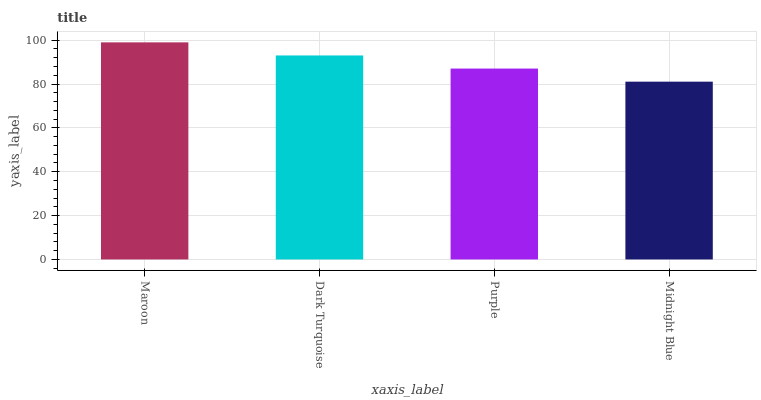Is Midnight Blue the minimum?
Answer yes or no. Yes. Is Maroon the maximum?
Answer yes or no. Yes. Is Dark Turquoise the minimum?
Answer yes or no. No. Is Dark Turquoise the maximum?
Answer yes or no. No. Is Maroon greater than Dark Turquoise?
Answer yes or no. Yes. Is Dark Turquoise less than Maroon?
Answer yes or no. Yes. Is Dark Turquoise greater than Maroon?
Answer yes or no. No. Is Maroon less than Dark Turquoise?
Answer yes or no. No. Is Dark Turquoise the high median?
Answer yes or no. Yes. Is Purple the low median?
Answer yes or no. Yes. Is Purple the high median?
Answer yes or no. No. Is Maroon the low median?
Answer yes or no. No. 